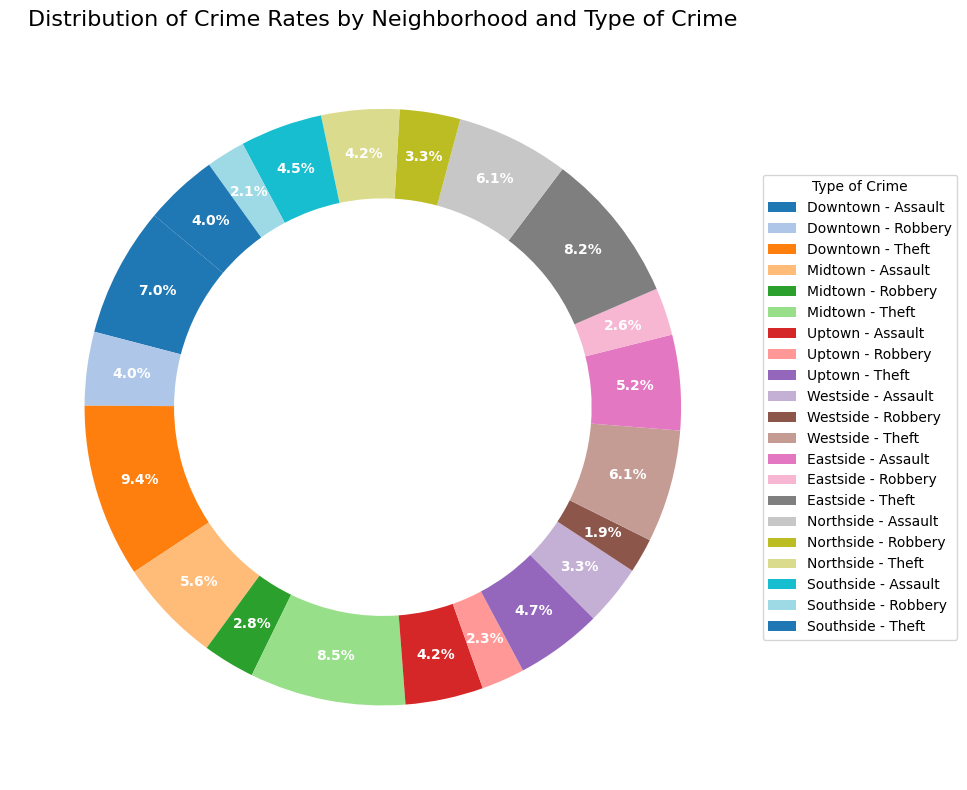what proportion of crimes in Downtown are Assaults? First, sum up all the crimes in Downtown: 150 (Assault) + 85 (Robbery) + 200 (Theft) = 435. Then, calculate the proportion of Assaults: 150/435 = 34.5%.
Answer: 34.5% Which neighborhood has the highest number of Thefts? Review the chart labels and find the theft counts: Downtown (200), Midtown (180), Uptown (100), Westside (130), Eastside (175), Northside (90), Southside (85). Downtown has the highest number.
Answer: Downtown How does the number of Assaults in Northside compare to Southside? Northside has 130 Assaults, while Southside has 95. Thus, Northside has more assaults than Southside.
Answer: Northside has more Which type of crime is the most frequent in Midtown? Review the chart labels for Midtown: Midtown Assault (120), Midtown Robbery (60), and Midtown Theft (180). The highest count is Theft at 180.
Answer: Theft What is the total number of crimes in Eastside? Add Eastside's crime counts: 110 (Assault) + 55 (Robbery) + 175 (Theft) = 340.
Answer: 340 Compare the total number of Robberies in Midtown and Uptown. Midtown has 60 Robberies, while Uptown has 50. Therefore, Midtown has more Robberies than Uptown.
Answer: Midtown has more How many more Thefts are there in Eastside compared to Westside? Eastside has 175 Thefts, while Westside has 130. The difference is 175 - 130 = 45.
Answer: 45 more What's the total proportion of Robberies in all neighborhoods combined? Sum up all Robberies: 85 + 60 + 50 + 40 + 55 + 70 + 45 = 405. Then, sum up all crimes: 150 + 85 + 200 + 120 + 60 + 180 + 90 + 50 + 100 + 70 + 40 + 130 + 110 + 55 + 175 + 130 + 70 + 90 + 95 + 45 + 85 = 2,080. The proportion is 405/2080 = 19.5%.
Answer: 19.5% Which neighborhood has the largest variety of crime types in similar proportions? Comparing the neighborhoods, Uptown (90-50-100) and Southside (95-45-85) have crime types in similar proportions, but Uptown seems more balanced between assault, robbery, and theft.
Answer: Uptown Compare the proportions of Theft in Westside and Southside. Westside has 130 Thefts out of 240 total crimes: 130/240 = 54.2%. Southside has 85 Thefts out of 225 total crimes: 85/225 = 37.8%. Therefore, Westside has a higher proportion of thefts.
Answer: Westside has a higher proportion 